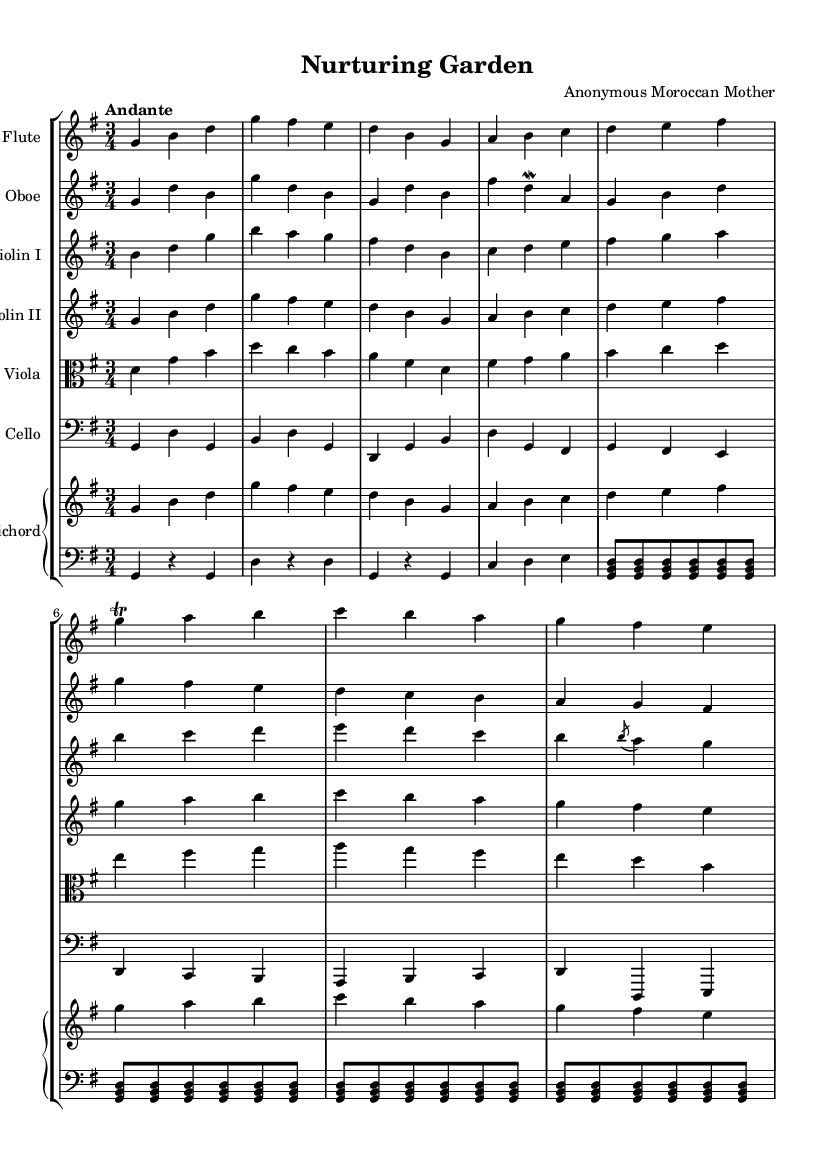What is the key signature of this music? The key signature is G major, which has one sharp (F#). This can be identified by looking at the key signature indicator at the beginning of the staff lines.
Answer: G major What is the time signature of this piece? The time signature is 3/4, indicating that there are three beats in each measure and the quarter note receives one beat. This is found in the notation at the beginning of the score.
Answer: 3/4 What is the tempo marking for this composition? The tempo marking reads "Andante," indicating a moderate tempo. This can be found written above the staff near the beginning of the score.
Answer: Andante How many instruments are there in this composition? There are six distinct instruments indicated in the score: flute, oboe, two violins (I and II), viola, cello, and harpsichord. This can be counted from the staff groupings present at the start of the score.
Answer: Six Which instrument plays the highest melodic line? The flute plays the highest melodic line as it is positioned on the uppermost staff and consistently reaches the highest pitches throughout the piece. This can be distinguished by observing the placement of the notes on the staves.
Answer: Flute What form of ornamentation is presented in the music? A trill is performed on the g note in the flute part, as indicated by the specific notation next to the note. This kind of ornamentation is characteristic of Baroque music.
Answer: Trill What quality of nature does this composition aim to convey? The composition evokes a nurturing quality of nature through its flowing melodies and gentle rhythms, which reflect a calm and soothing garden atmosphere. This can be inferred from the title "Nurturing Garden" and the overall feel of the piece.
Answer: Nurturing 